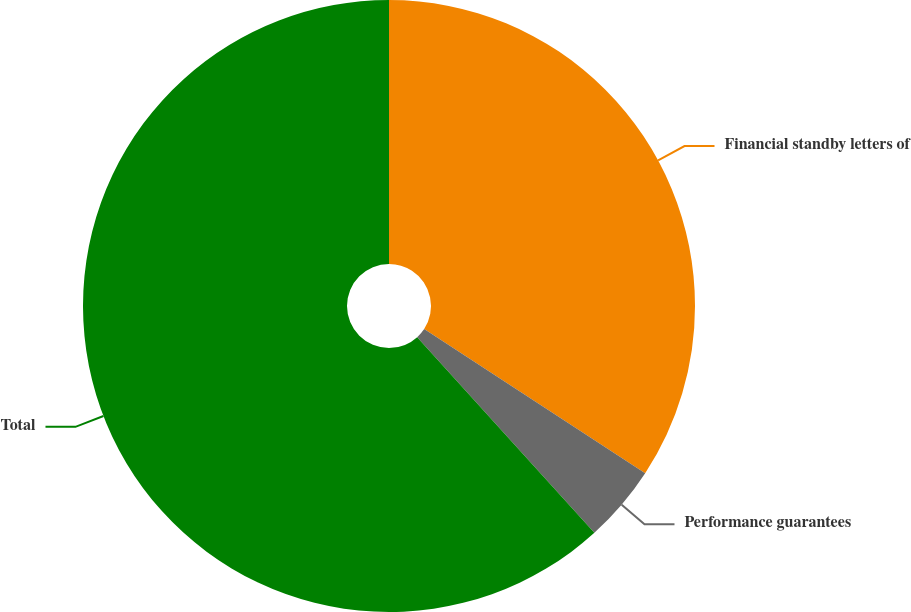Convert chart. <chart><loc_0><loc_0><loc_500><loc_500><pie_chart><fcel>Financial standby letters of<fcel>Performance guarantees<fcel>Total<nl><fcel>34.21%<fcel>4.08%<fcel>61.71%<nl></chart> 